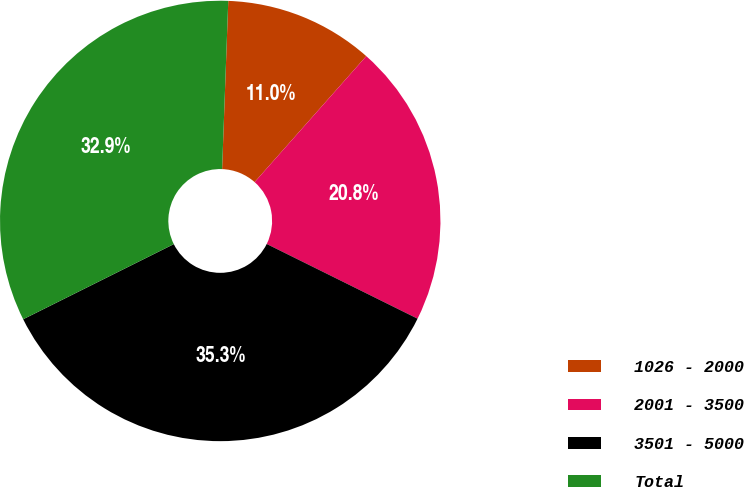Convert chart. <chart><loc_0><loc_0><loc_500><loc_500><pie_chart><fcel>1026 - 2000<fcel>2001 - 3500<fcel>3501 - 5000<fcel>Total<nl><fcel>10.96%<fcel>20.78%<fcel>35.32%<fcel>32.95%<nl></chart> 